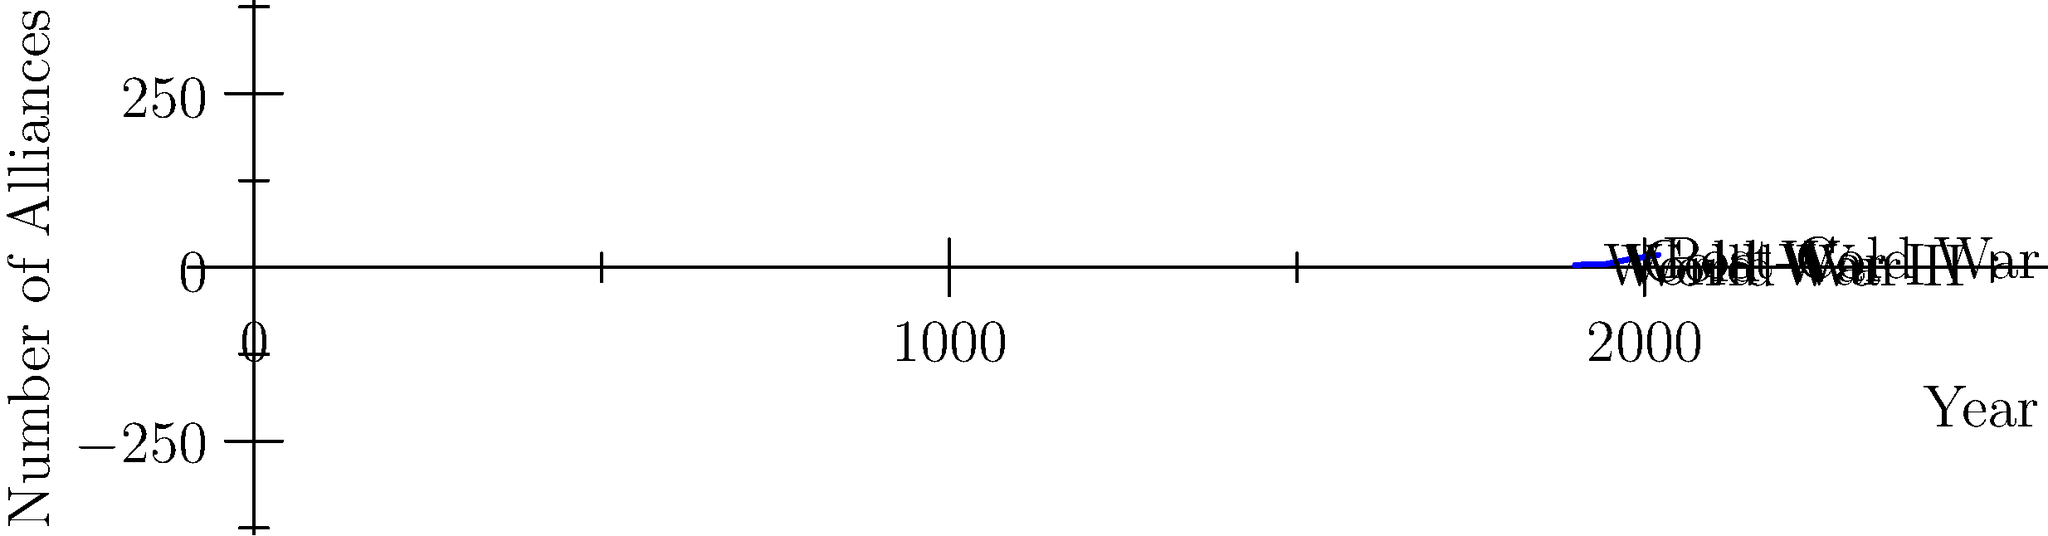Based on the timeline graph showing the evolution of international alliances over time, which historical period saw the steepest increase in the number of alliances, and what factors might have contributed to this trend? To answer this question, we need to analyze the graph and consider historical context:

1. Examine the graph's slope at different periods:
   - 1900-1920: Slight increase
   - 1920-1940: Slight decrease
   - 1940-1960: Moderate increase
   - 1960-1980: Steep increase
   - 1980-2000: Moderate increase
   - 2000-2020: Slight increase

2. Identify the steepest increase: 1960-1980

3. Consider historical context for this period:
   - This corresponds to the height of the Cold War
   - Bipolar world order: USA vs. USSR
   - Formation of opposing blocs (NATO vs. Warsaw Pact)
   - Proxy wars and regional conflicts
   - Decolonization leading to new independent states seeking alliances

4. Factors contributing to the increase in alliances:
   - Security concerns in a tense global environment
   - Ideological alignment with superpowers
   - Economic and military aid incentives
   - Regional cooperation to balance against superpowers
   - Newly independent states seeking protection and support

5. Compare to other periods:
   - Post-Cold War era (1990s-2000s) shows a slower increase
   - World Wars (1914-1918 and 1939-1945) show less dramatic changes
Answer: The Cold War period (1960-1980), due to superpower competition, bloc formation, and decolonization. 